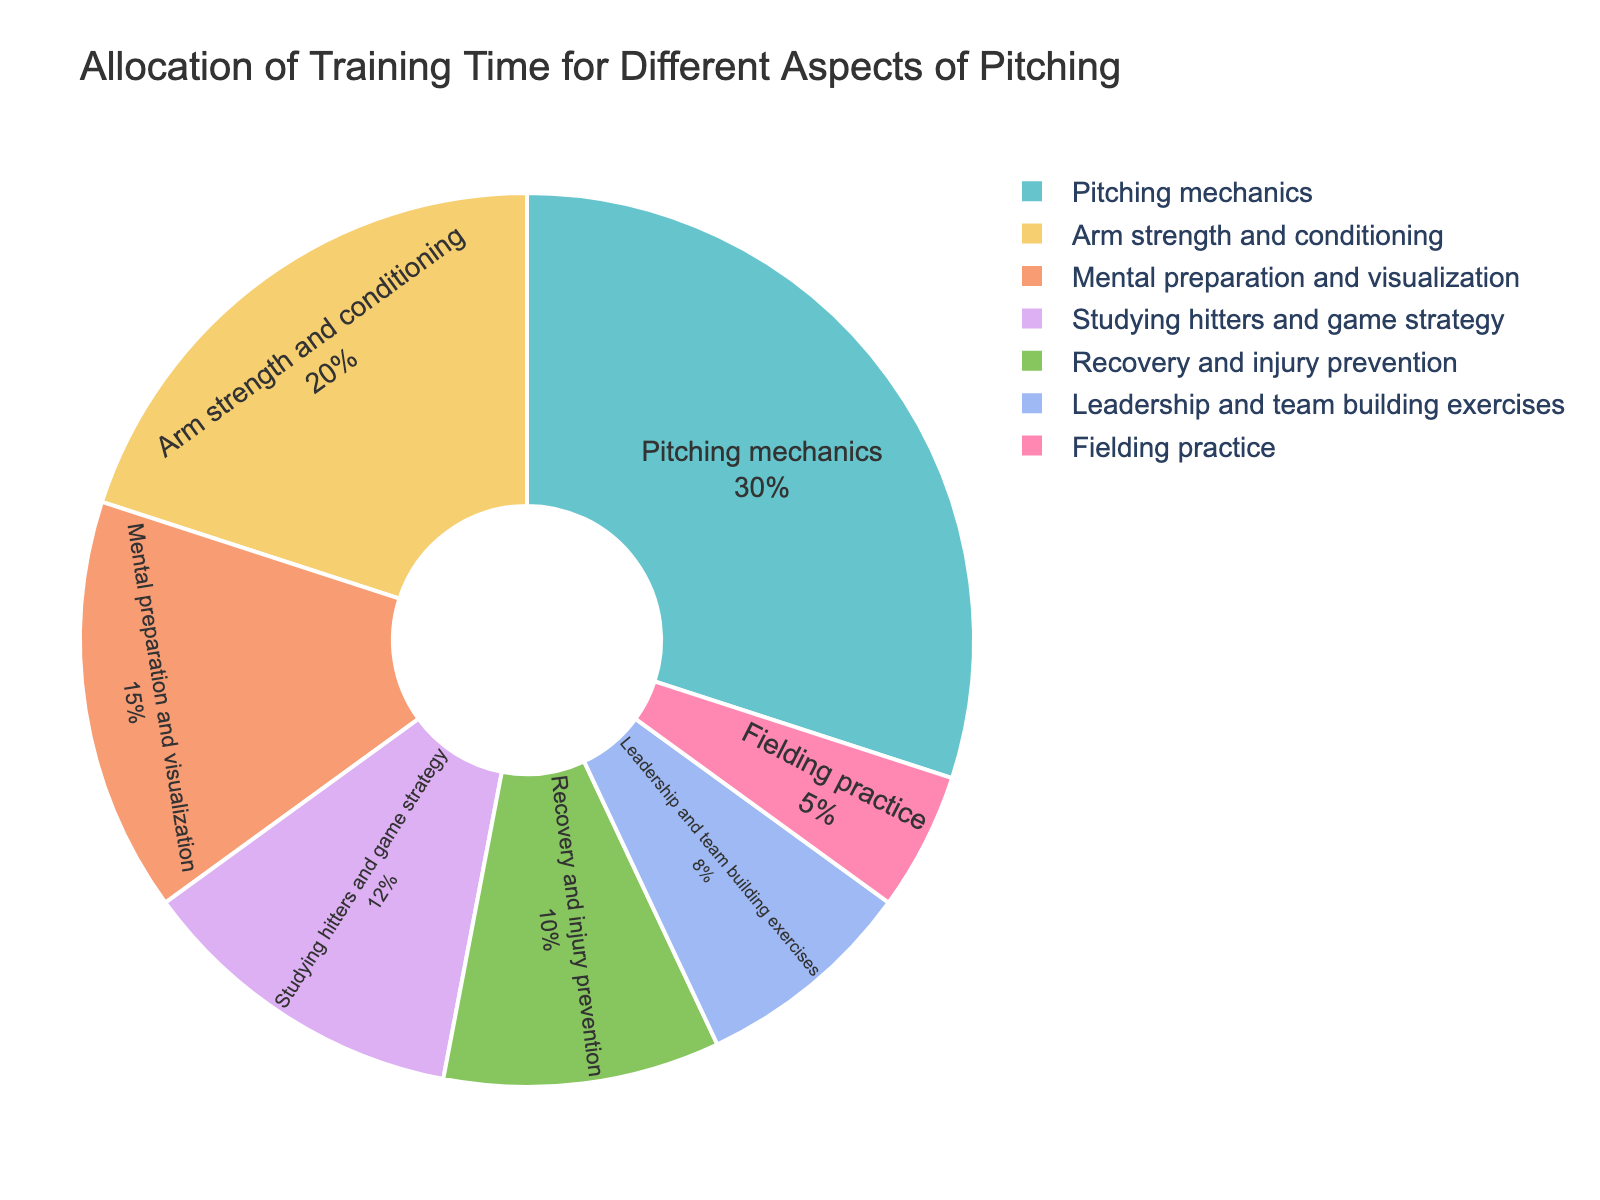What percentage of training time is dedicated to mental preparation and visualization? Look at the pie chart slice labeled “Mental preparation and visualization” to identify its percentage.
Answer: 15% How much more time is allocated to pitching mechanics compared to arm strength and conditioning? Find the percentages for “Pitching mechanics” (30%) and “Arm strength and conditioning” (20%), and subtract the latter from the former: 30% - 20% = 10%.
Answer: 10% Which aspect of training is given the least amount of time? Look for the smallest slice in the pie chart, which is “Fielding practice” with 5%.
Answer: Fielding practice What is the combined percentage of time spent on leadership and team building exercises and fielding practice? Add the percentages for “Leadership and team building exercises” (8%) and “Fielding practice” (5%): 8% + 5% = 13%.
Answer: 13% Is more time spent on recovery and injury prevention or studying hitters and game strategy? Compare the slices for “Recovery and injury prevention” (10%) and “Studying hitters and game strategy” (12%); the latter has a higher percentage.
Answer: Studying hitters and game strategy What is the difference in the percentage of training time between the most allocated and least allocated aspects? Find the highest (Pitching mechanics, 30%) and lowest (Fielding practice, 5%) percentages and subtract the latter from the former: 30% - 5% = 25%.
Answer: 25% How does the time allocated to arm strength and conditioning compare to that for mental preparation and visualization? Compare the percentages for “Arm strength and conditioning” (20%) and “Mental preparation and visualization” (15%). Arm strength and conditioning has a higher percentage.
Answer: Arm strength and conditioning What percentage of time is spent on activities directly related to physical conditioning (Pitching mechanics, Arm strength, Recovery)? Sum the percentages for “Pitching mechanics” (30%), “Arm strength and conditioning” (20%), and “Recovery and injury prevention” (10%): 30% + 20% + 10% = 60%.
Answer: 60% Which two aspects combined account for a quarter of the total training time? Look for slices that add up to 25%. “Mental preparation and visualization” (15%) and "Recovery and injury prevention" (10%) together total 25%.
Answer: Mental preparation and visualization and Recovery and injury prevention What visual cues indicate that the aspect with the highest percentage is “Pitching mechanics”? The largest slice in the pie chart, indicated by its greater area, is labeled “Pitching mechanics” and corresponds to 30%.
Answer: Largest slice with “Pitching mechanics” label 